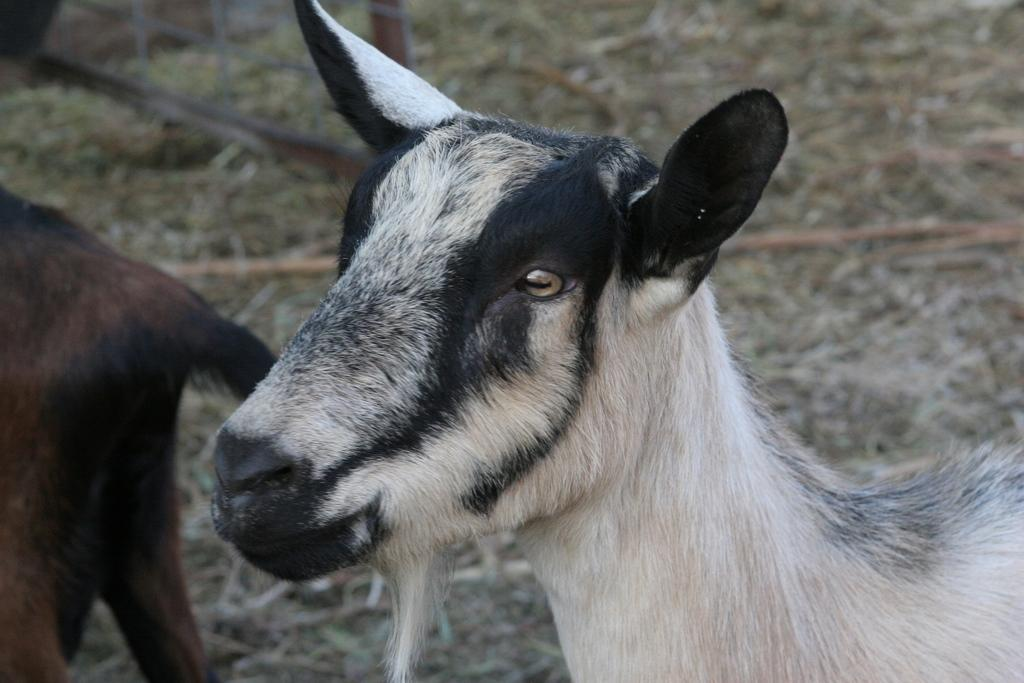What type of animal is present in the image? There is a goat in the image. Can you describe the color pattern of the goat? The goat has a white and black color pattern. Are there any other goats in the image? Yes, there is another goat in the image. What is the color of the second goat? The second goat has a brown color. What type of key is the goat holding in the image? There is no key present in the image; the goats are not holding anything. 